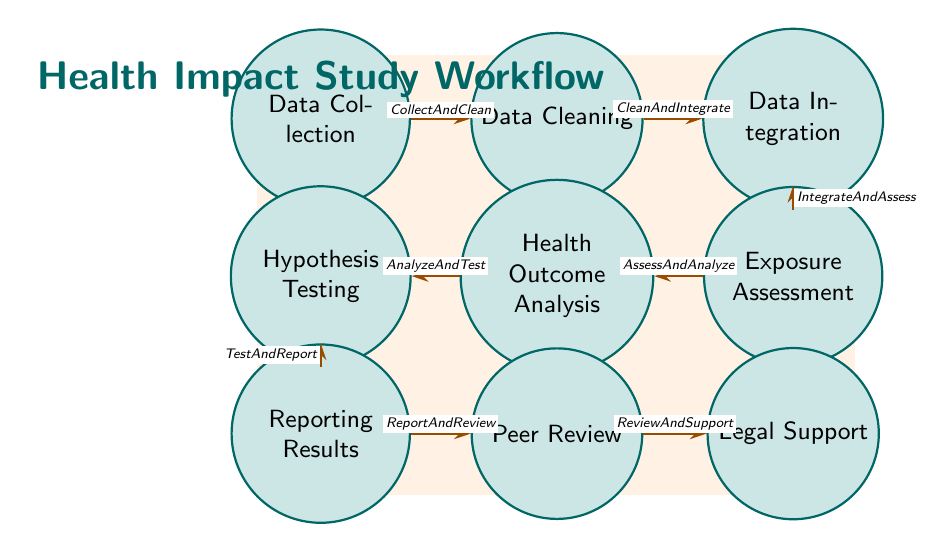What state follows Data Collection? According to the transitions in the diagram, Data Cleaning is the state that comes directly after Data Collection.
Answer: Data Cleaning How many states are present in the diagram? By counting the nodes labeled in the diagram, there are a total of nine states in the workflow.
Answer: Nine What is the last state in the workflow? The final state is Legal Support, which is positioned as the last node in the flow of transitions.
Answer: Legal Support What transition occurs after Health Outcome Analysis? The transition that occurs after Health Outcome Analysis is labeled AnalyzeAndTest.
Answer: AnalyzeAndTest Which method is used for estimating pollution exposure levels? The method used for estimating pollution exposure levels, as mentioned in the Exposure Assessment state, is the geographic information system (GIS).
Answer: Geographic Information System (GIS) What is the edge label between Reporting Results and Peer Review? The edge label between Reporting Results and Peer Review is ReportAndReview, indicating the transition between these two states.
Answer: ReportAndReview Which two states are connected by the transition named IntegrateAndAssess? The transition named IntegrateAndAssess connects the states Data Integration and Exposure Assessment, as shown in the diagram's flow.
Answer: Data Integration and Exposure Assessment In which state is hypothesis testing performed? Hypothesis testing is performed in the state labeled Hypothesis Testing, which follows Health Outcome Analysis in the workflow.
Answer: Hypothesis Testing Which state comes before Data Integration? According to the diagram, the state that comes before Data Integration is Data Cleaning, as indicated by the transition CleanAndIntegrate.
Answer: Data Cleaning 